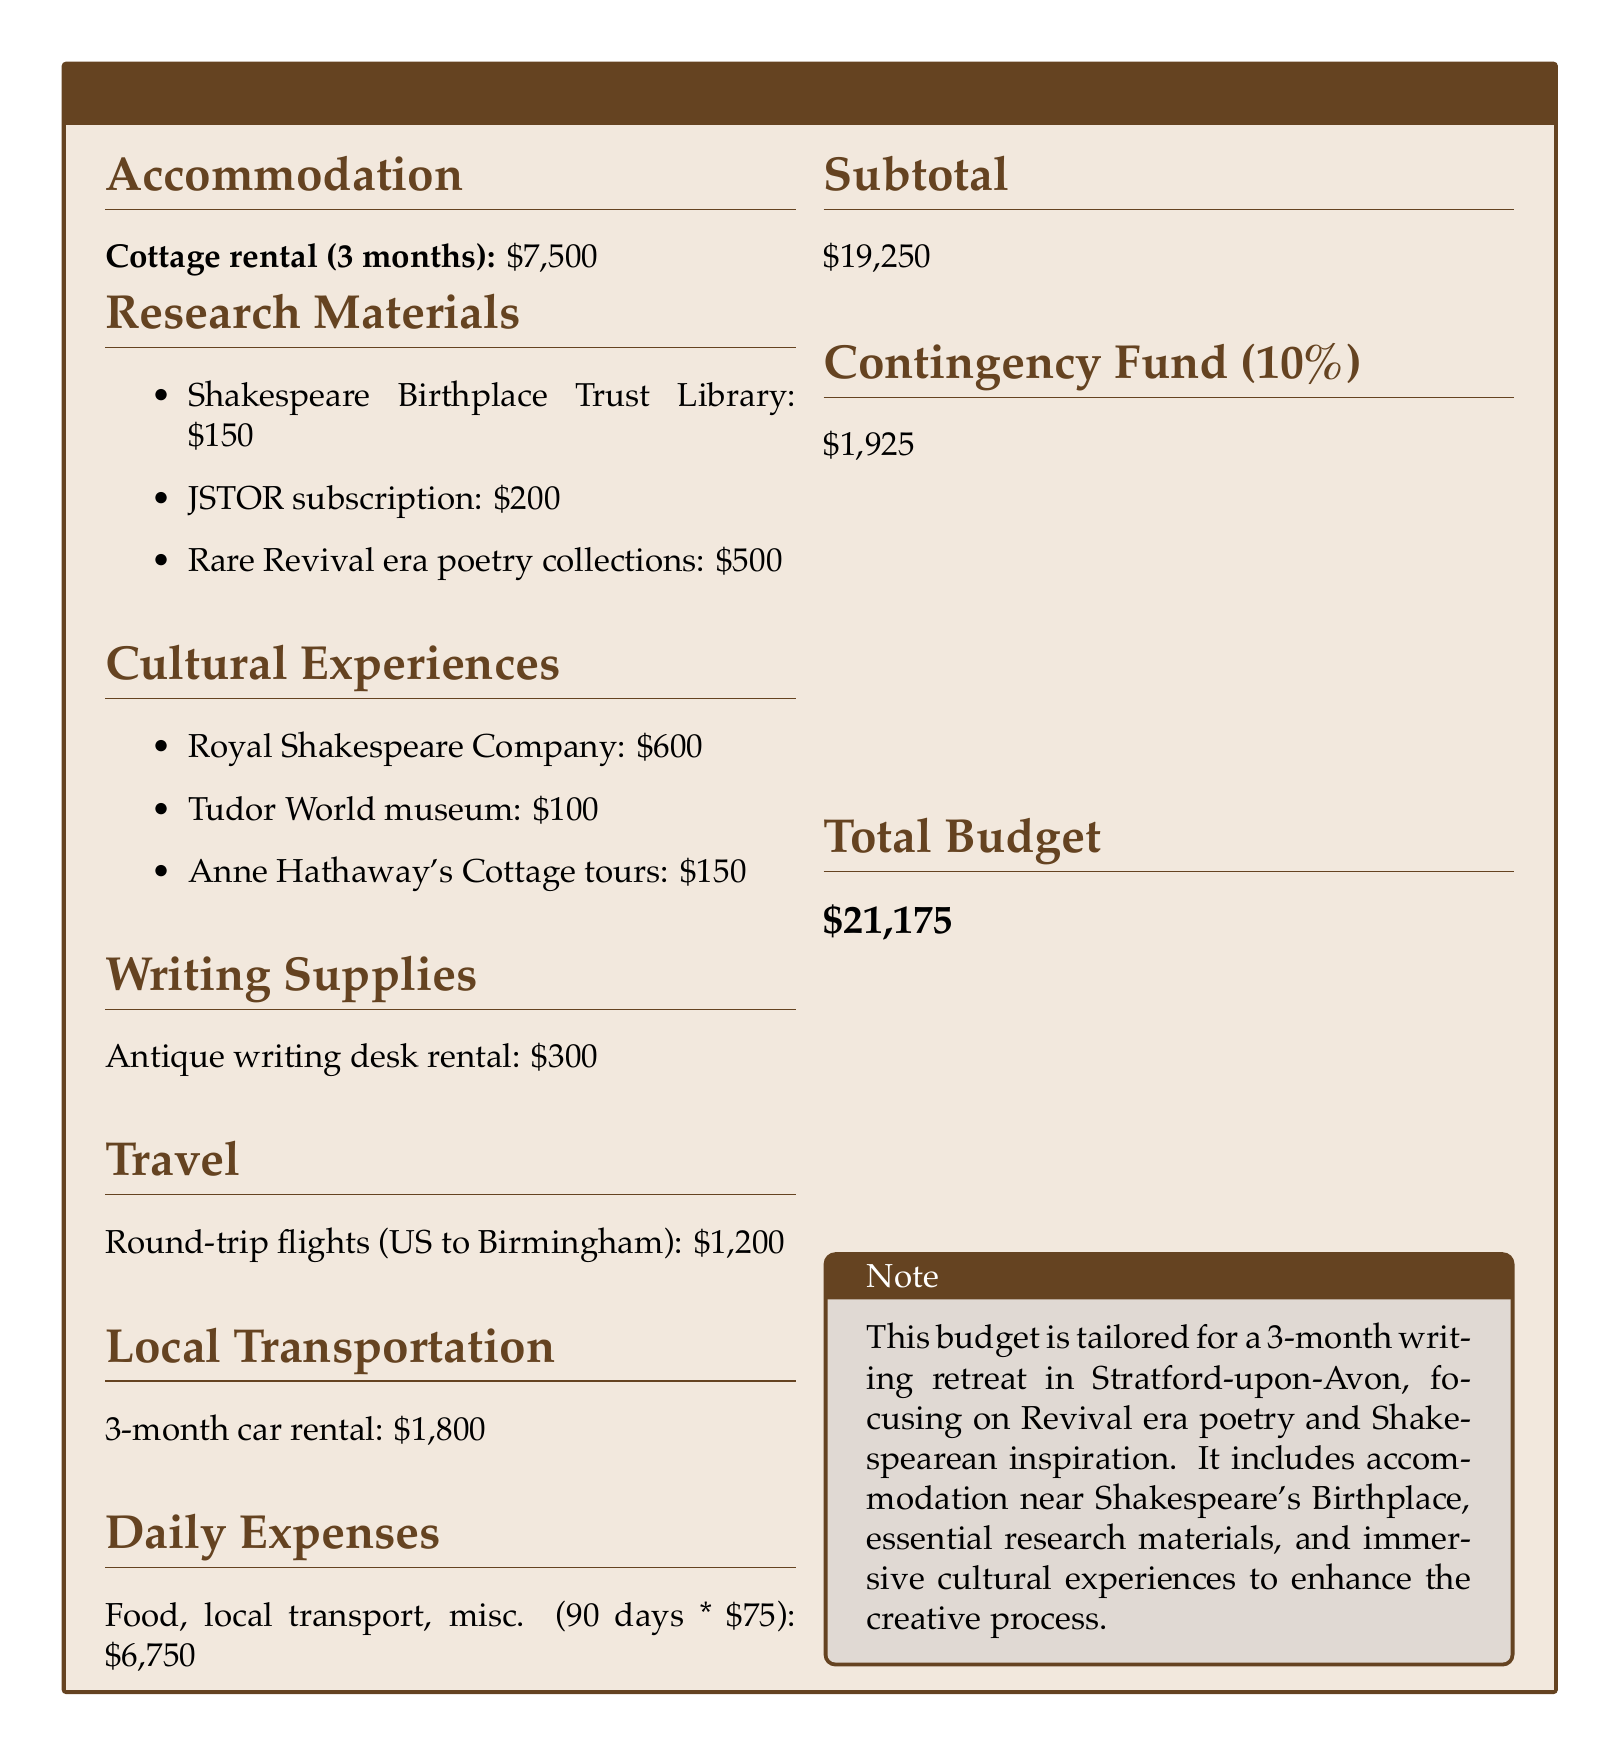What is the total budget? The total budget is listed at the bottom of the document, which includes all expenses and the contingency fund.
Answer: $21,175 How much is allocated for accommodation? The budget specifies the cottage rental cost for the writing retreat, which is indicated in the accommodation section.
Answer: $7,500 What is the cost for research materials? The total for research materials is calculated by summing individual costs listed under the research materials section.
Answer: $850 What is the daily expense amount? The daily expenses are calculated based on the number of days (90) multiplied by the daily cost of $75 for food and local transport.
Answer: $6,750 How long is the writing retreat planned for? The document mentions the duration of the writing retreat in the note section, which gives context to the budget.
Answer: 3 months What percentage is allocated to the contingency fund? The contingency fund is specified as a percentage of the subtotal in the document.
Answer: 10% How much is budgeted for cultural experiences? The cultural experiences section lists individual costs that need to be summed to find the total.
Answer: $850 What is the cost of the antique writing desk rental? The document explicitly states the cost for the writing supplies, including the rental of the antique writing desk.
Answer: $300 What organization is associated with the cultural experiences? The document specifies an organization related to one of the cultural experiences for the writing retreat.
Answer: Royal Shakespeare Company 